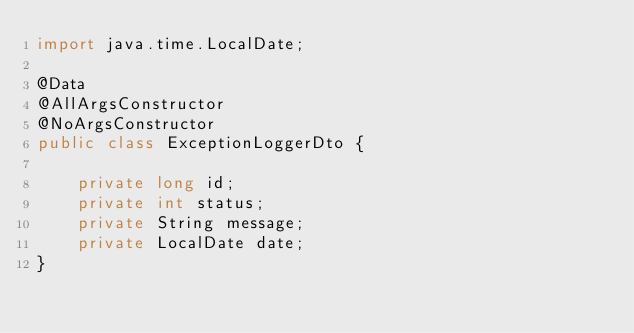Convert code to text. <code><loc_0><loc_0><loc_500><loc_500><_Java_>import java.time.LocalDate;

@Data
@AllArgsConstructor
@NoArgsConstructor
public class ExceptionLoggerDto {

    private long id;
    private int status;
    private String message;
    private LocalDate date;
}
</code> 